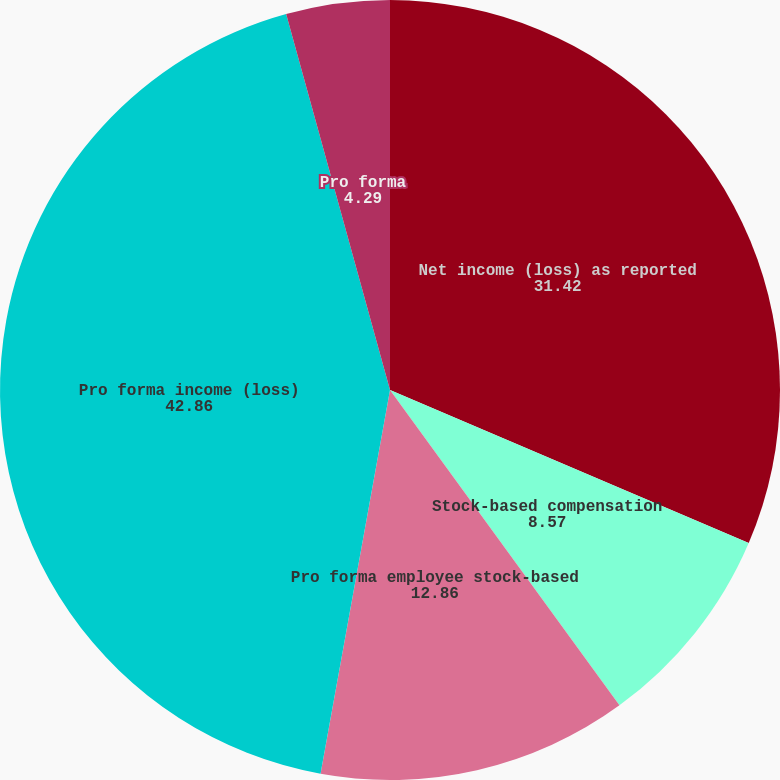Convert chart. <chart><loc_0><loc_0><loc_500><loc_500><pie_chart><fcel>Net income (loss) as reported<fcel>Stock-based compensation<fcel>Pro forma employee stock-based<fcel>Pro forma income (loss)<fcel>As reported<fcel>Pro forma<nl><fcel>31.42%<fcel>8.57%<fcel>12.86%<fcel>42.86%<fcel>0.0%<fcel>4.29%<nl></chart> 